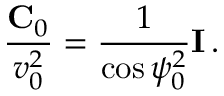Convert formula to latex. <formula><loc_0><loc_0><loc_500><loc_500>\frac { { C } _ { 0 } } { v _ { 0 } ^ { 2 } } = \frac { 1 } { \cos \psi _ { 0 } ^ { 2 } } { I } \, .</formula> 